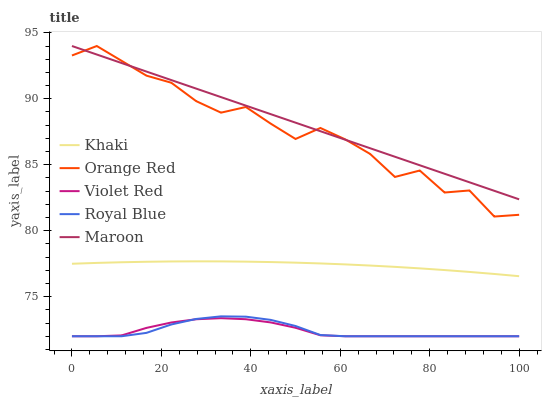Does Khaki have the minimum area under the curve?
Answer yes or no. No. Does Khaki have the maximum area under the curve?
Answer yes or no. No. Is Violet Red the smoothest?
Answer yes or no. No. Is Violet Red the roughest?
Answer yes or no. No. Does Khaki have the lowest value?
Answer yes or no. No. Does Khaki have the highest value?
Answer yes or no. No. Is Khaki less than Orange Red?
Answer yes or no. Yes. Is Orange Red greater than Royal Blue?
Answer yes or no. Yes. Does Khaki intersect Orange Red?
Answer yes or no. No. 